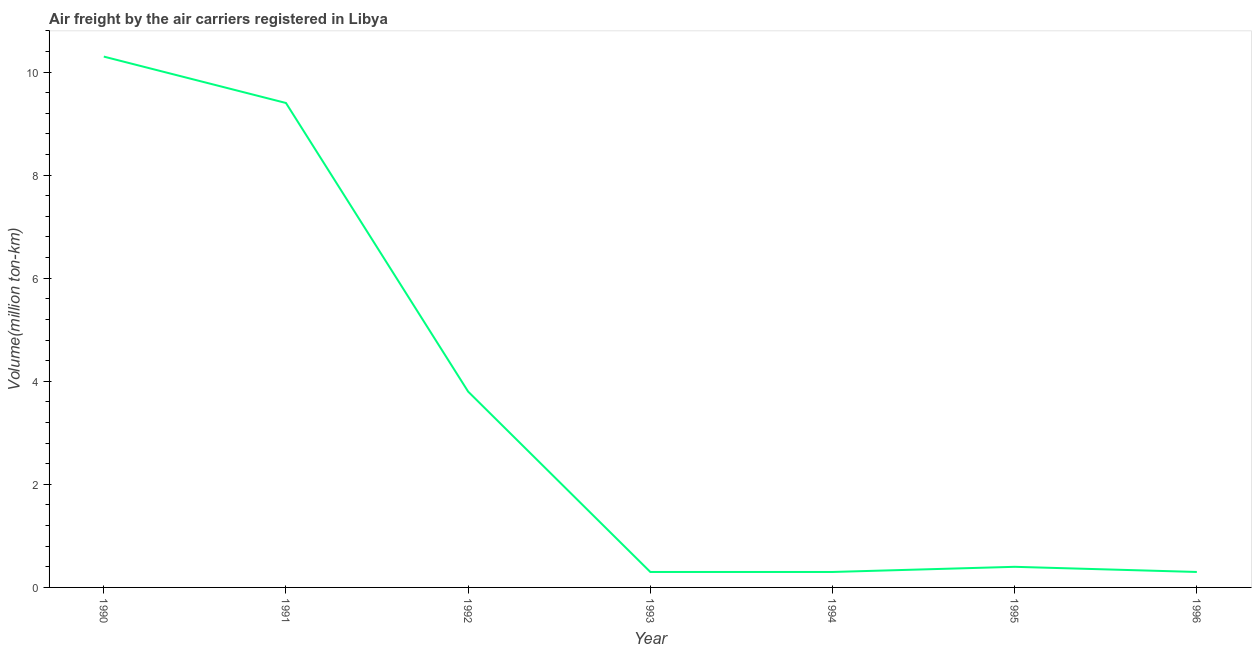What is the air freight in 1994?
Offer a terse response. 0.3. Across all years, what is the maximum air freight?
Keep it short and to the point. 10.3. Across all years, what is the minimum air freight?
Your answer should be very brief. 0.3. In which year was the air freight maximum?
Keep it short and to the point. 1990. In which year was the air freight minimum?
Ensure brevity in your answer.  1993. What is the sum of the air freight?
Keep it short and to the point. 24.8. What is the difference between the air freight in 1990 and 1996?
Ensure brevity in your answer.  10. What is the average air freight per year?
Make the answer very short. 3.54. What is the median air freight?
Provide a succinct answer. 0.4. Do a majority of the years between 1995 and 1996 (inclusive) have air freight greater than 10.4 million ton-km?
Offer a very short reply. No. What is the ratio of the air freight in 1994 to that in 1996?
Provide a short and direct response. 1. Is the difference between the air freight in 1990 and 1994 greater than the difference between any two years?
Ensure brevity in your answer.  Yes. What is the difference between the highest and the second highest air freight?
Keep it short and to the point. 0.9. Is the sum of the air freight in 1990 and 1994 greater than the maximum air freight across all years?
Your response must be concise. Yes. What is the difference between the highest and the lowest air freight?
Your answer should be compact. 10. Does the air freight monotonically increase over the years?
Your answer should be very brief. No. What is the title of the graph?
Your answer should be compact. Air freight by the air carriers registered in Libya. What is the label or title of the X-axis?
Make the answer very short. Year. What is the label or title of the Y-axis?
Give a very brief answer. Volume(million ton-km). What is the Volume(million ton-km) in 1990?
Your response must be concise. 10.3. What is the Volume(million ton-km) of 1991?
Your answer should be compact. 9.4. What is the Volume(million ton-km) of 1992?
Make the answer very short. 3.8. What is the Volume(million ton-km) of 1993?
Your answer should be very brief. 0.3. What is the Volume(million ton-km) of 1994?
Provide a short and direct response. 0.3. What is the Volume(million ton-km) of 1995?
Your answer should be very brief. 0.4. What is the Volume(million ton-km) in 1996?
Ensure brevity in your answer.  0.3. What is the difference between the Volume(million ton-km) in 1990 and 1992?
Provide a short and direct response. 6.5. What is the difference between the Volume(million ton-km) in 1990 and 1996?
Your answer should be compact. 10. What is the difference between the Volume(million ton-km) in 1991 and 1993?
Offer a terse response. 9.1. What is the difference between the Volume(million ton-km) in 1991 and 1995?
Your answer should be very brief. 9. What is the difference between the Volume(million ton-km) in 1992 and 1996?
Give a very brief answer. 3.5. What is the difference between the Volume(million ton-km) in 1993 and 1994?
Offer a very short reply. 0. What is the difference between the Volume(million ton-km) in 1994 and 1995?
Give a very brief answer. -0.1. What is the difference between the Volume(million ton-km) in 1994 and 1996?
Provide a succinct answer. 0. What is the ratio of the Volume(million ton-km) in 1990 to that in 1991?
Your answer should be very brief. 1.1. What is the ratio of the Volume(million ton-km) in 1990 to that in 1992?
Offer a terse response. 2.71. What is the ratio of the Volume(million ton-km) in 1990 to that in 1993?
Your answer should be very brief. 34.33. What is the ratio of the Volume(million ton-km) in 1990 to that in 1994?
Provide a succinct answer. 34.33. What is the ratio of the Volume(million ton-km) in 1990 to that in 1995?
Your answer should be very brief. 25.75. What is the ratio of the Volume(million ton-km) in 1990 to that in 1996?
Make the answer very short. 34.33. What is the ratio of the Volume(million ton-km) in 1991 to that in 1992?
Provide a succinct answer. 2.47. What is the ratio of the Volume(million ton-km) in 1991 to that in 1993?
Offer a terse response. 31.33. What is the ratio of the Volume(million ton-km) in 1991 to that in 1994?
Ensure brevity in your answer.  31.33. What is the ratio of the Volume(million ton-km) in 1991 to that in 1995?
Make the answer very short. 23.5. What is the ratio of the Volume(million ton-km) in 1991 to that in 1996?
Make the answer very short. 31.33. What is the ratio of the Volume(million ton-km) in 1992 to that in 1993?
Give a very brief answer. 12.67. What is the ratio of the Volume(million ton-km) in 1992 to that in 1994?
Provide a succinct answer. 12.67. What is the ratio of the Volume(million ton-km) in 1992 to that in 1996?
Your answer should be very brief. 12.67. What is the ratio of the Volume(million ton-km) in 1993 to that in 1996?
Give a very brief answer. 1. What is the ratio of the Volume(million ton-km) in 1994 to that in 1996?
Provide a short and direct response. 1. What is the ratio of the Volume(million ton-km) in 1995 to that in 1996?
Make the answer very short. 1.33. 